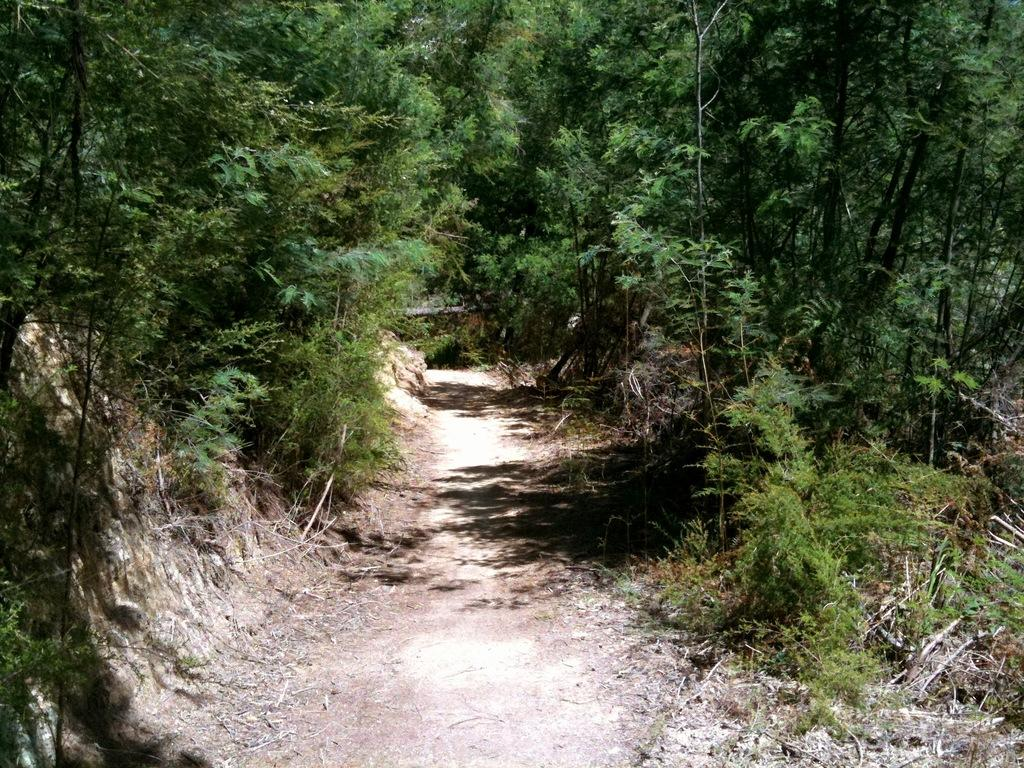What can be seen running through the vegetation in the image? There is a path in the image that runs through the vegetation. What type of vegetation is present on both sides of the path? Plants and trees are present on both sides of the path. How many years has the ant been living on the path in the image? There is no ant present in the image, so it is not possible to determine how long an ant might have been living on the path. 